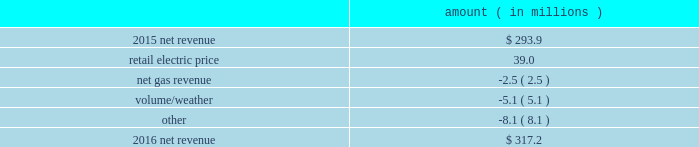Entergy new orleans , inc .
And subsidiaries management 2019s financial discussion and analysis results of operations net income 2016 compared to 2015 net income increased $ 3.9 million primarily due to higher net revenue , partially offset by higher depreciation and amortization expenses , higher interest expense , and lower other income .
2015 compared to 2014 net income increased $ 13.9 million primarily due to lower other operation and maintenance expenses and higher net revenue , partially offset by a higher effective income tax rate .
Net revenue 2016 compared to 2015 net revenue consists of operating revenues net of : 1 ) fuel , fuel-related expenses , and gas purchased for resale , 2 ) purchased power expenses , and 3 ) other regulatory charges .
Following is an analysis of the change in net revenue comparing 2016 to 2015 .
Amount ( in millions ) .
The retail electric price variance is primarily due to an increase in the purchased power and capacity acquisition cost recovery rider , as approved by the city council , effective with the first billing cycle of march 2016 , primarily related to the purchase of power block 1 of the union power station .
See note 14 to the financial statements for discussion of the union power station purchase .
The net gas revenue variance is primarily due to the effect of less favorable weather on residential and commercial sales .
The volume/weather variance is primarily due to a decrease of 112 gwh , or 2% ( 2 % ) , in billed electricity usage , partially offset by the effect of favorable weather on commercial sales and a 2% ( 2 % ) increase in the average number of electric customers. .
What is the growth rate in net revenue in 2016 for entergy new orleans , inc? 
Computations: ((317.2 - 293.9) / 293.9)
Answer: 0.07928. 